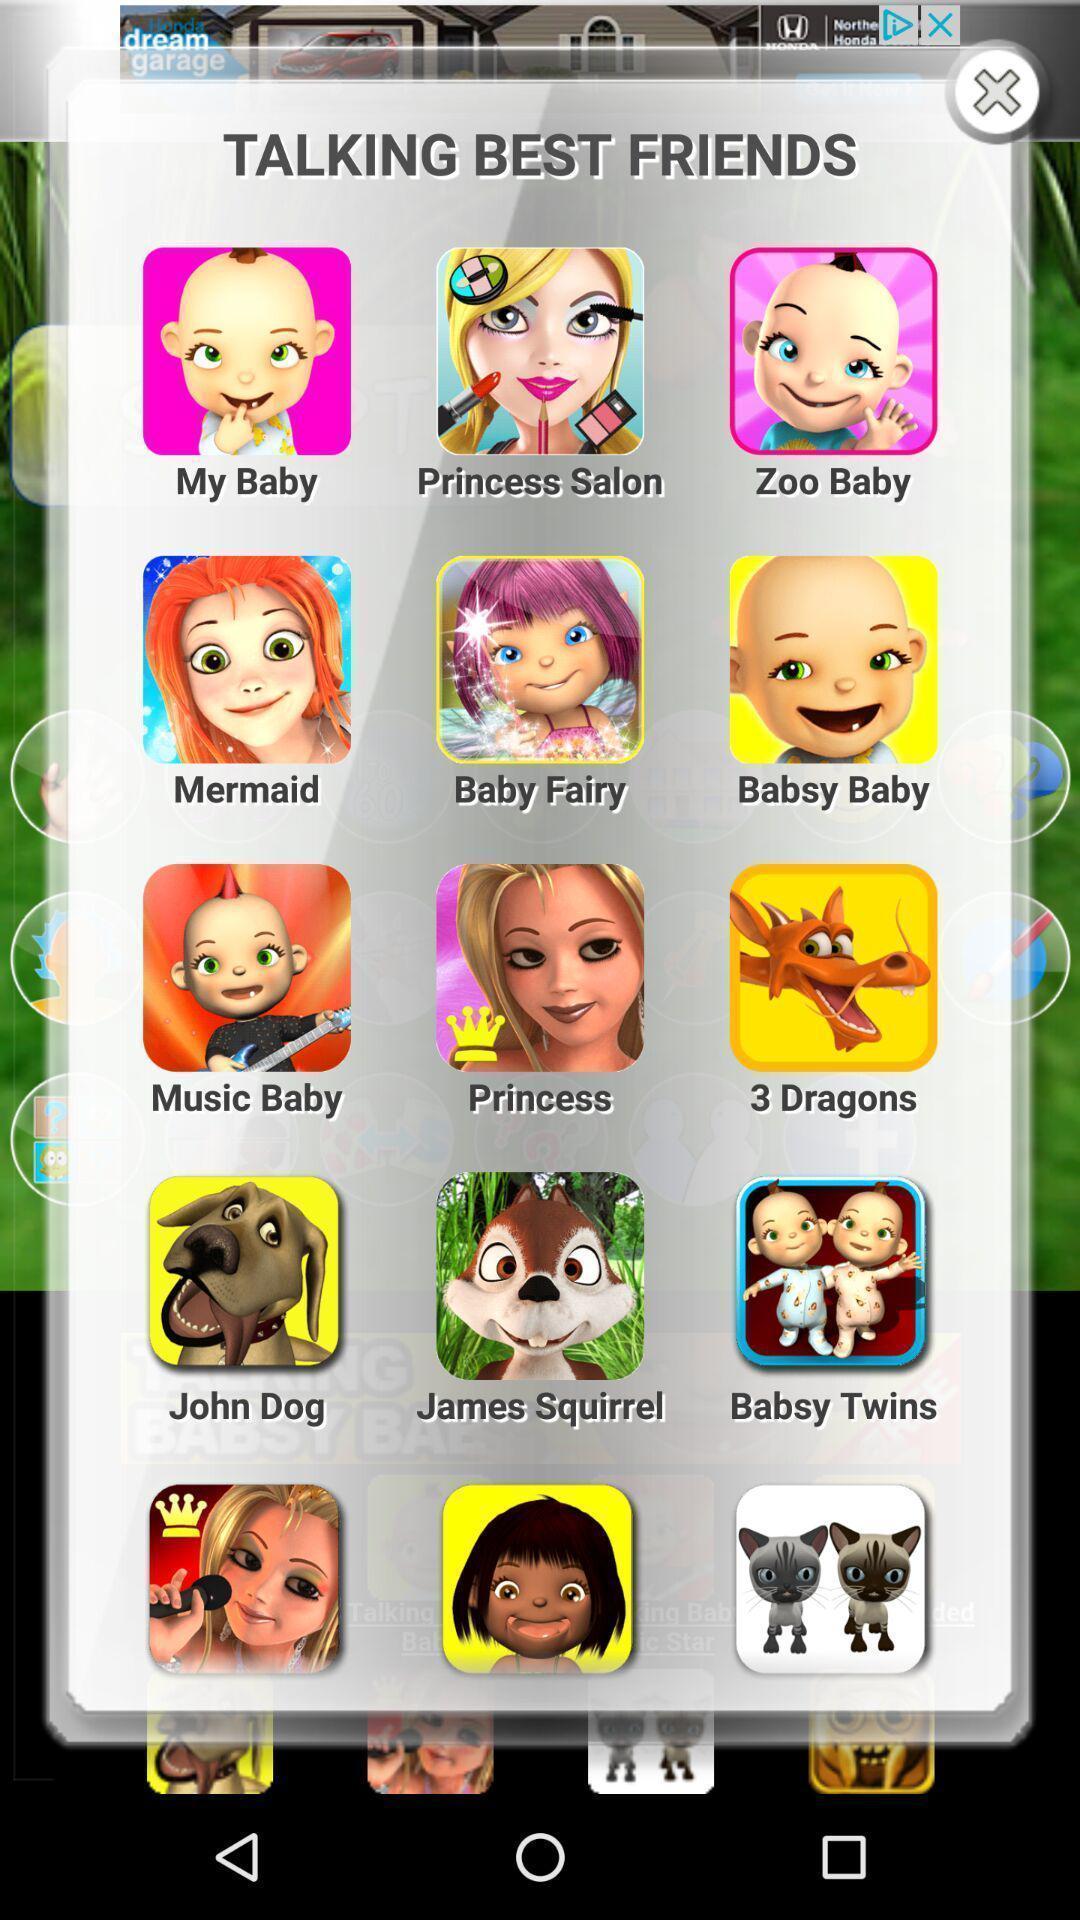Describe this image in words. Screen displaying different icons and options. 